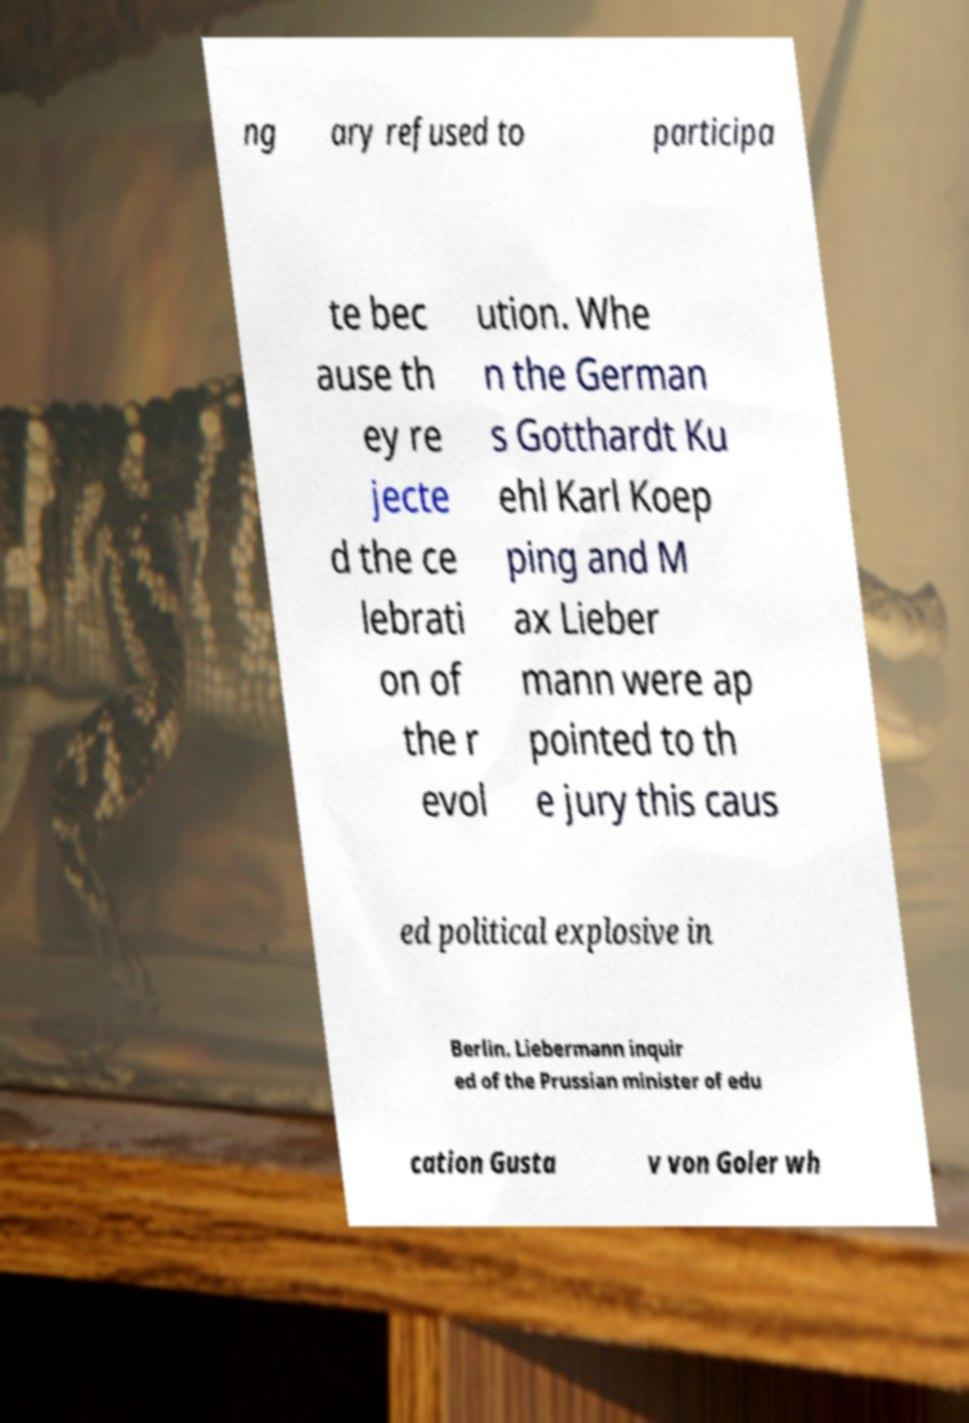I need the written content from this picture converted into text. Can you do that? ng ary refused to participa te bec ause th ey re jecte d the ce lebrati on of the r evol ution. Whe n the German s Gotthardt Ku ehl Karl Koep ping and M ax Lieber mann were ap pointed to th e jury this caus ed political explosive in Berlin. Liebermann inquir ed of the Prussian minister of edu cation Gusta v von Goler wh 